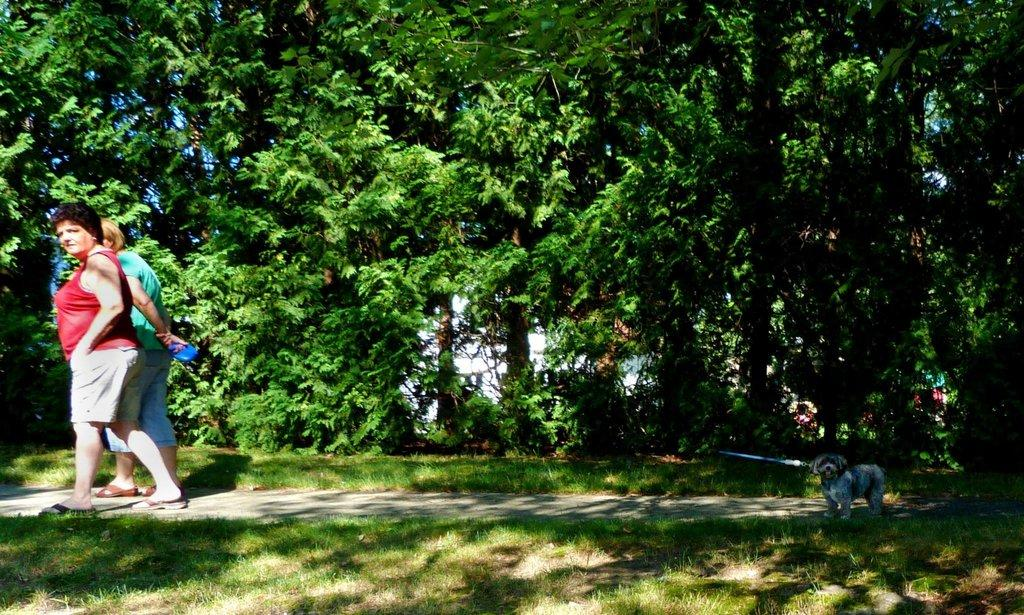What are the two persons in the image doing? The two persons in the image are walking. What type of animal is present in the image? There is a puppy in the image. What is the ground made of in the image? There is grass on the ground in the image. What type of vegetation can be seen in the image? There are plants and trees in the image. What type of wood is the puppy chewing on in the image? There is no wood present in the image, and the puppy is not chewing on anything. 